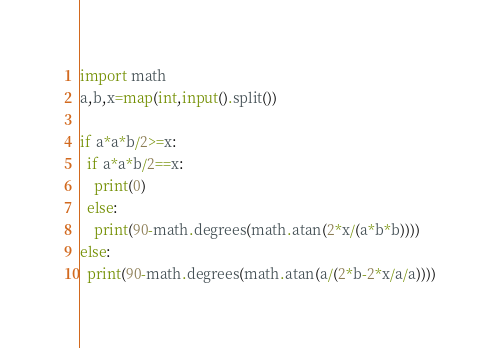<code> <loc_0><loc_0><loc_500><loc_500><_Python_>import math
a,b,x=map(int,input().split())

if a*a*b/2>=x:
  if a*a*b/2==x:
    print(0)
  else:
    print(90-math.degrees(math.atan(2*x/(a*b*b))))
else:
  print(90-math.degrees(math.atan(a/(2*b-2*x/a/a))))</code> 